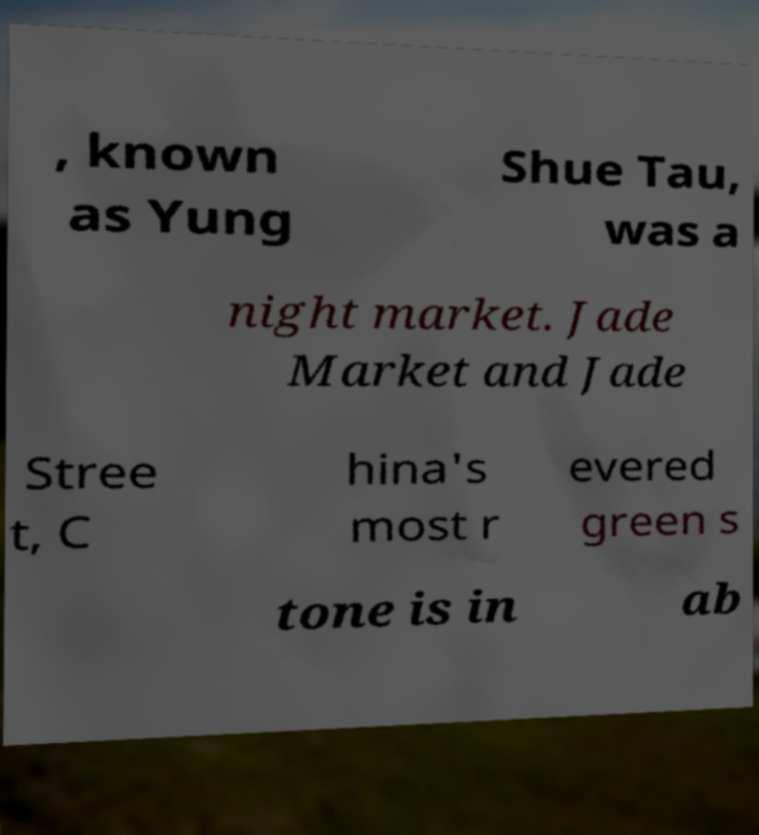Please identify and transcribe the text found in this image. , known as Yung Shue Tau, was a night market. Jade Market and Jade Stree t, C hina's most r evered green s tone is in ab 